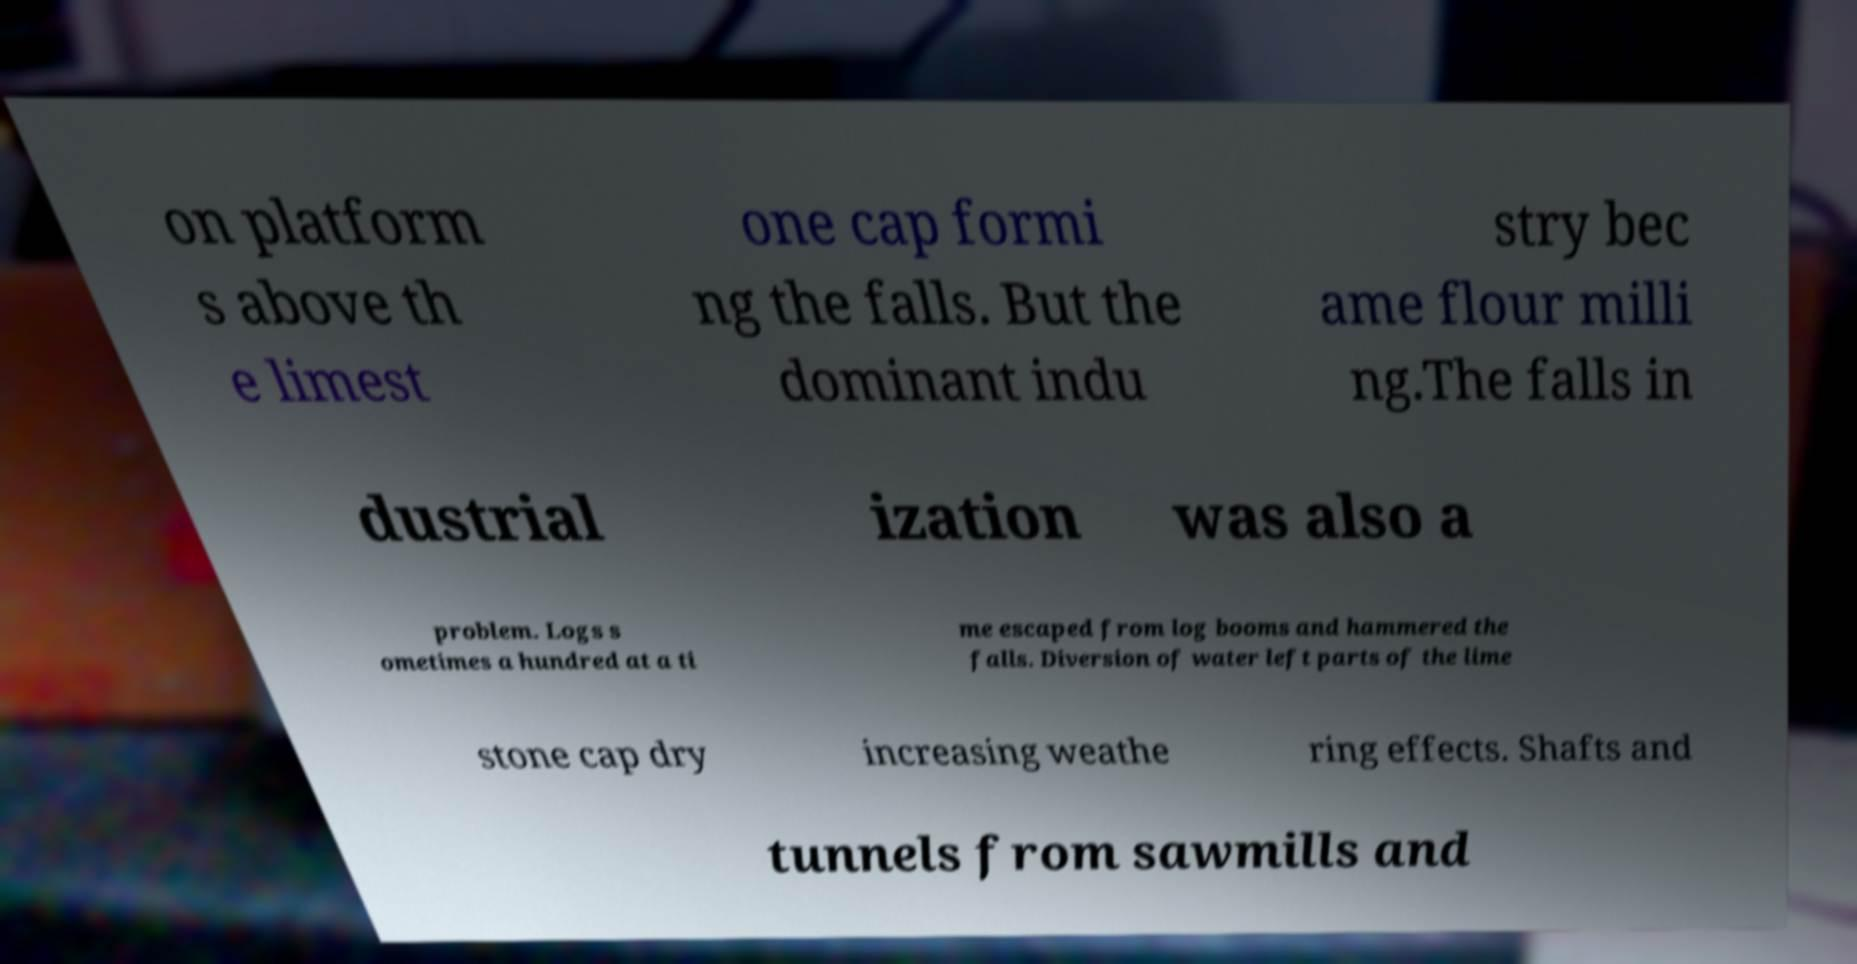Could you extract and type out the text from this image? on platform s above th e limest one cap formi ng the falls. But the dominant indu stry bec ame flour milli ng.The falls in dustrial ization was also a problem. Logs s ometimes a hundred at a ti me escaped from log booms and hammered the falls. Diversion of water left parts of the lime stone cap dry increasing weathe ring effects. Shafts and tunnels from sawmills and 